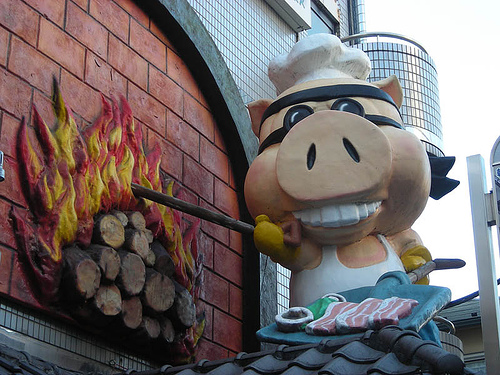<image>
Can you confirm if the pig is behind the fire? No. The pig is not behind the fire. From this viewpoint, the pig appears to be positioned elsewhere in the scene. 